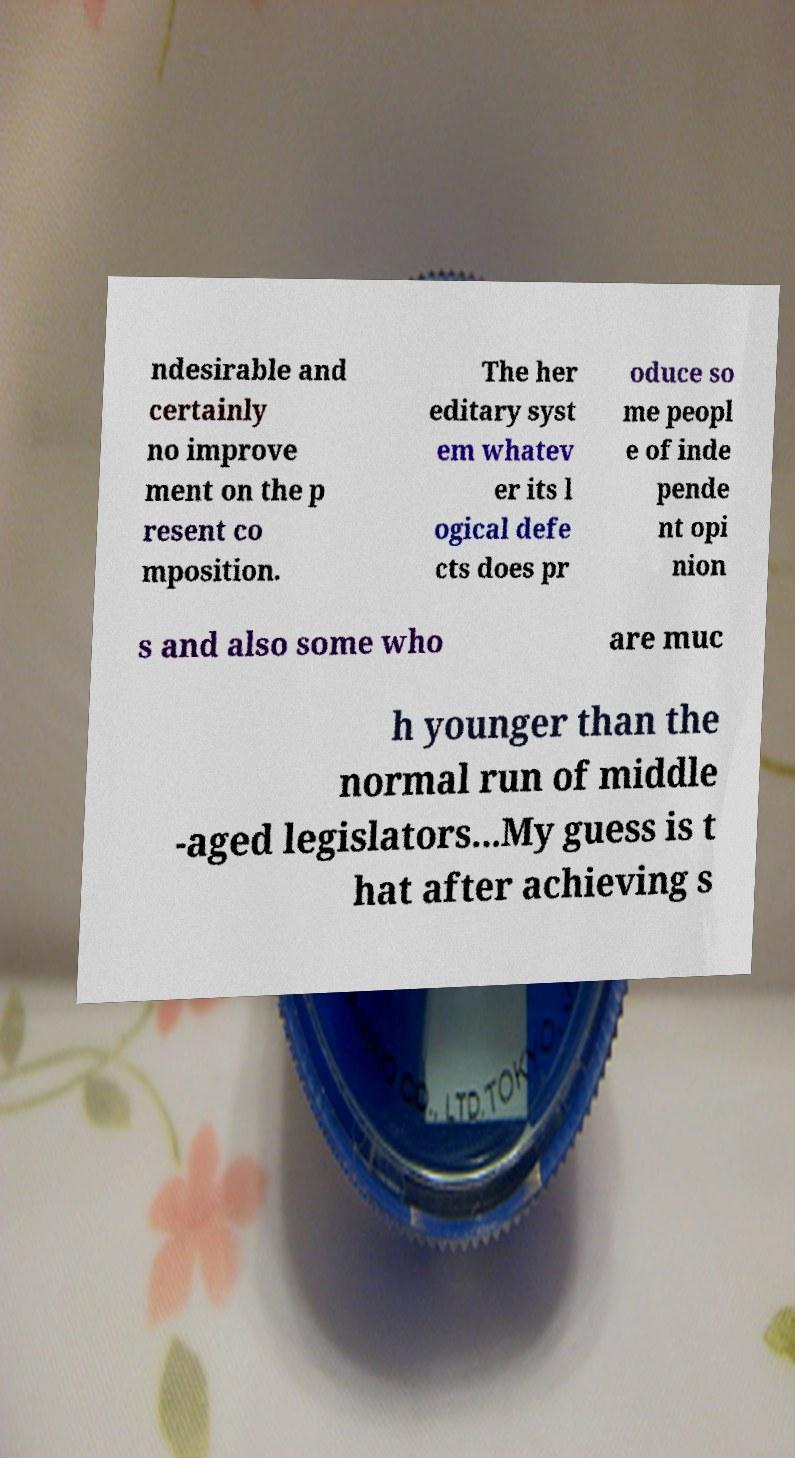For documentation purposes, I need the text within this image transcribed. Could you provide that? ndesirable and certainly no improve ment on the p resent co mposition. The her editary syst em whatev er its l ogical defe cts does pr oduce so me peopl e of inde pende nt opi nion s and also some who are muc h younger than the normal run of middle -aged legislators...My guess is t hat after achieving s 